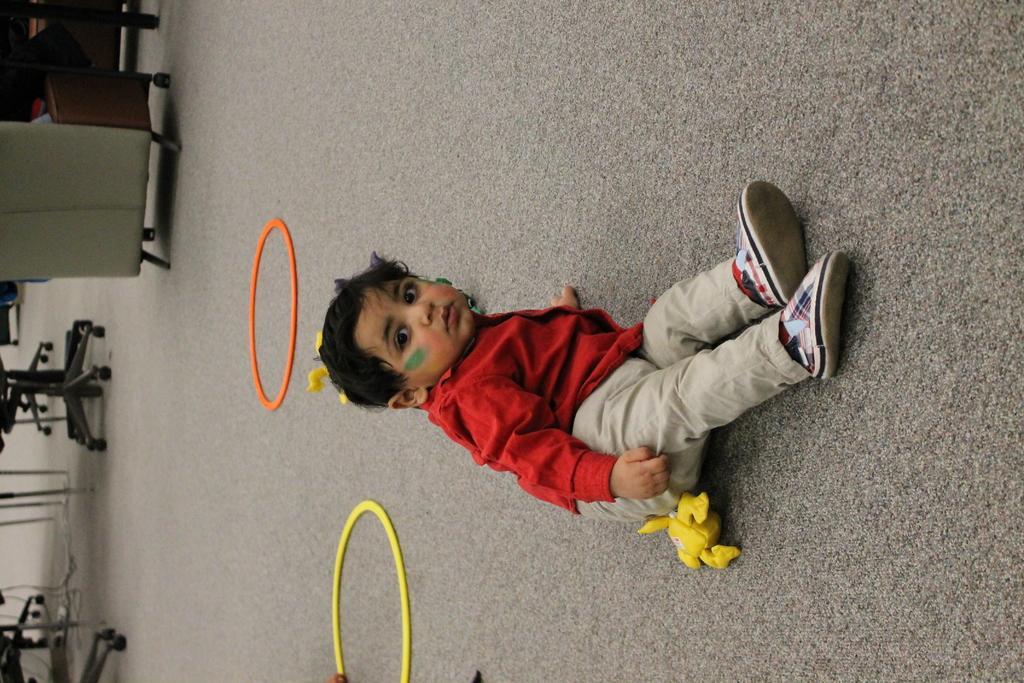In one or two sentences, can you explain what this image depicts? In this image we can see a kid wearing red color shirt, cream color pant sitting on the ground and on left side of the image there are some chairs and table. 